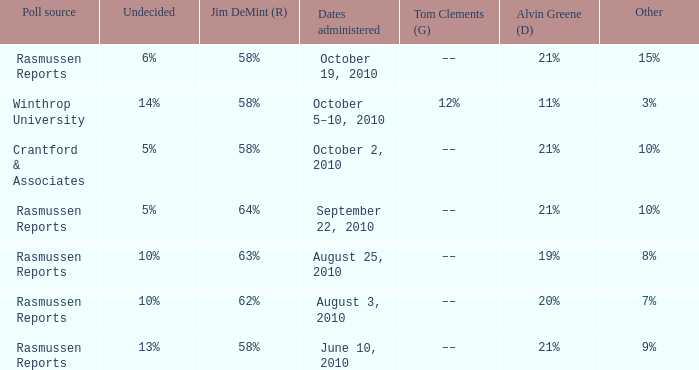What was the vote for Alvin Green when Jim DeMint was 62%? 20%. 